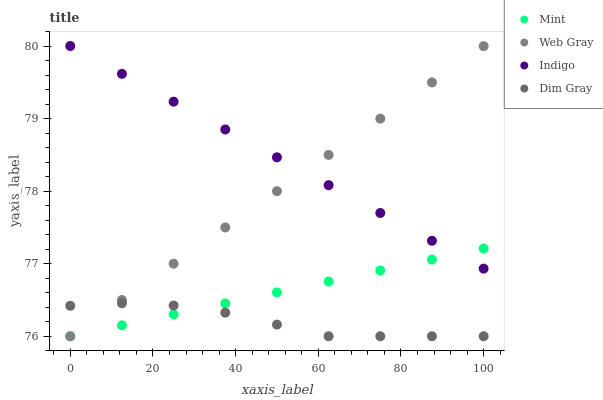Does Dim Gray have the minimum area under the curve?
Answer yes or no. Yes. Does Indigo have the maximum area under the curve?
Answer yes or no. Yes. Does Web Gray have the minimum area under the curve?
Answer yes or no. No. Does Web Gray have the maximum area under the curve?
Answer yes or no. No. Is Mint the smoothest?
Answer yes or no. Yes. Is Dim Gray the roughest?
Answer yes or no. Yes. Is Web Gray the smoothest?
Answer yes or no. No. Is Web Gray the roughest?
Answer yes or no. No. Does Dim Gray have the lowest value?
Answer yes or no. Yes. Does Indigo have the highest value?
Answer yes or no. Yes. Does Web Gray have the highest value?
Answer yes or no. No. Is Dim Gray less than Indigo?
Answer yes or no. Yes. Is Indigo greater than Dim Gray?
Answer yes or no. Yes. Does Web Gray intersect Dim Gray?
Answer yes or no. Yes. Is Web Gray less than Dim Gray?
Answer yes or no. No. Is Web Gray greater than Dim Gray?
Answer yes or no. No. Does Dim Gray intersect Indigo?
Answer yes or no. No. 